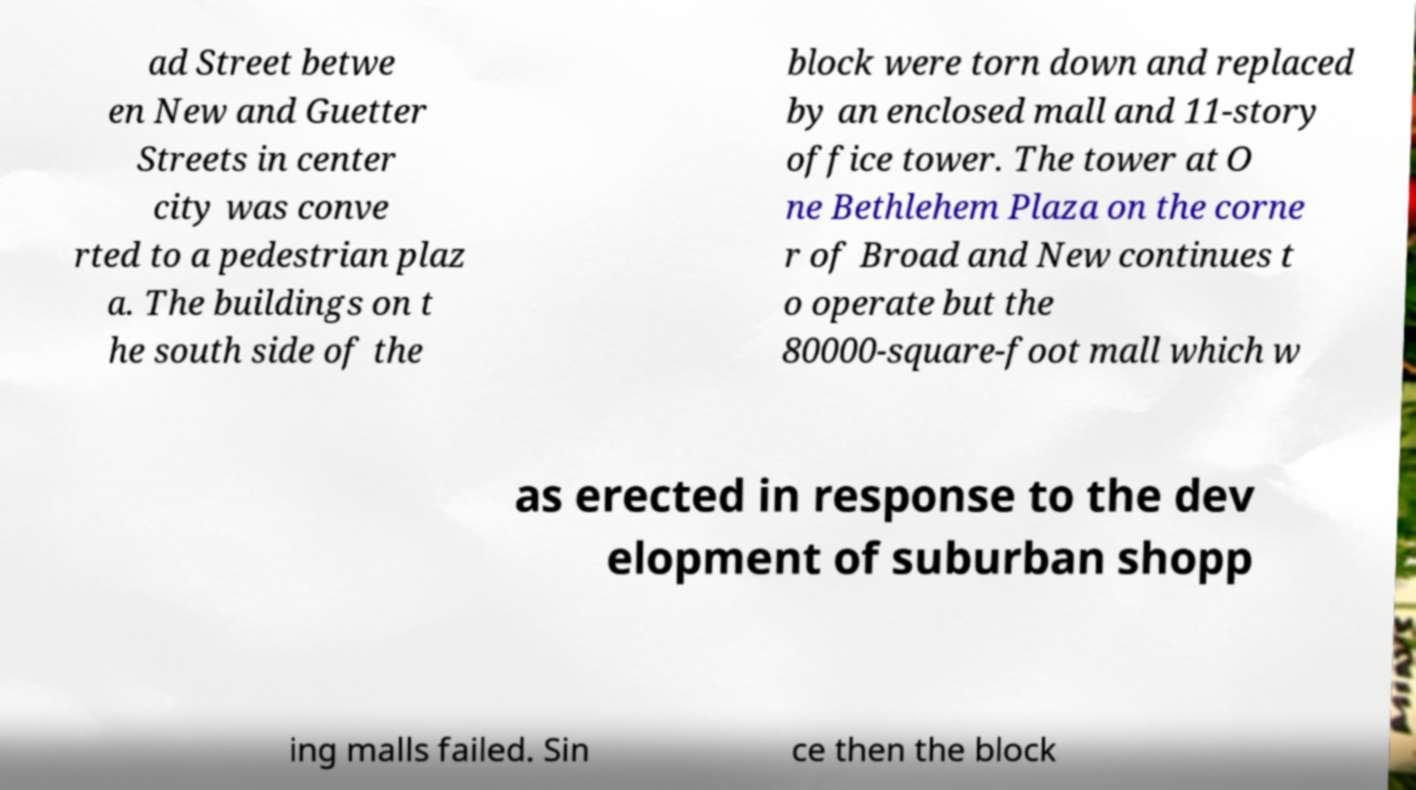There's text embedded in this image that I need extracted. Can you transcribe it verbatim? ad Street betwe en New and Guetter Streets in center city was conve rted to a pedestrian plaz a. The buildings on t he south side of the block were torn down and replaced by an enclosed mall and 11-story office tower. The tower at O ne Bethlehem Plaza on the corne r of Broad and New continues t o operate but the 80000-square-foot mall which w as erected in response to the dev elopment of suburban shopp ing malls failed. Sin ce then the block 